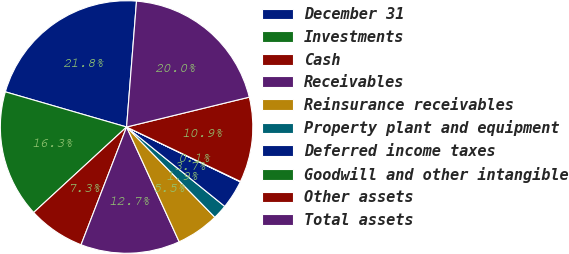Convert chart to OTSL. <chart><loc_0><loc_0><loc_500><loc_500><pie_chart><fcel>December 31<fcel>Investments<fcel>Cash<fcel>Receivables<fcel>Reinsurance receivables<fcel>Property plant and equipment<fcel>Deferred income taxes<fcel>Goodwill and other intangible<fcel>Other assets<fcel>Total assets<nl><fcel>21.76%<fcel>16.33%<fcel>7.29%<fcel>12.71%<fcel>5.48%<fcel>1.86%<fcel>3.67%<fcel>0.05%<fcel>10.9%<fcel>19.95%<nl></chart> 